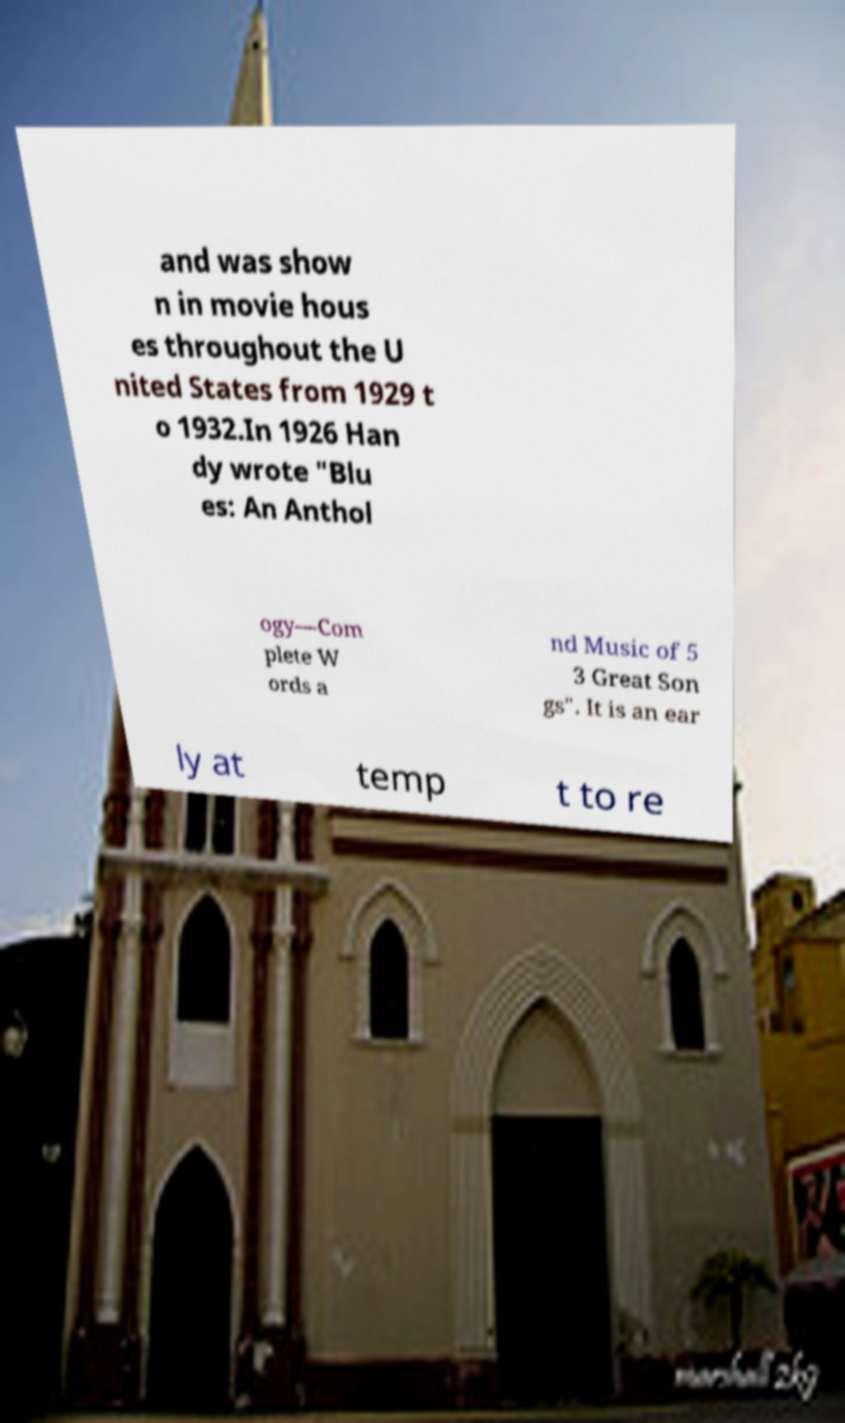Can you read and provide the text displayed in the image?This photo seems to have some interesting text. Can you extract and type it out for me? and was show n in movie hous es throughout the U nited States from 1929 t o 1932.In 1926 Han dy wrote "Blu es: An Anthol ogy—Com plete W ords a nd Music of 5 3 Great Son gs". It is an ear ly at temp t to re 